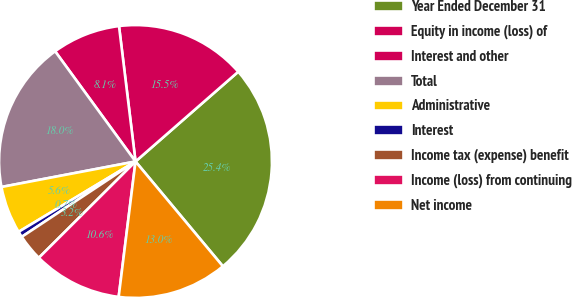Convert chart. <chart><loc_0><loc_0><loc_500><loc_500><pie_chart><fcel>Year Ended December 31<fcel>Equity in income (loss) of<fcel>Interest and other<fcel>Total<fcel>Administrative<fcel>Interest<fcel>Income tax (expense) benefit<fcel>Income (loss) from continuing<fcel>Net income<nl><fcel>25.37%<fcel>15.5%<fcel>8.1%<fcel>17.96%<fcel>5.63%<fcel>0.69%<fcel>3.16%<fcel>10.56%<fcel>13.03%<nl></chart> 